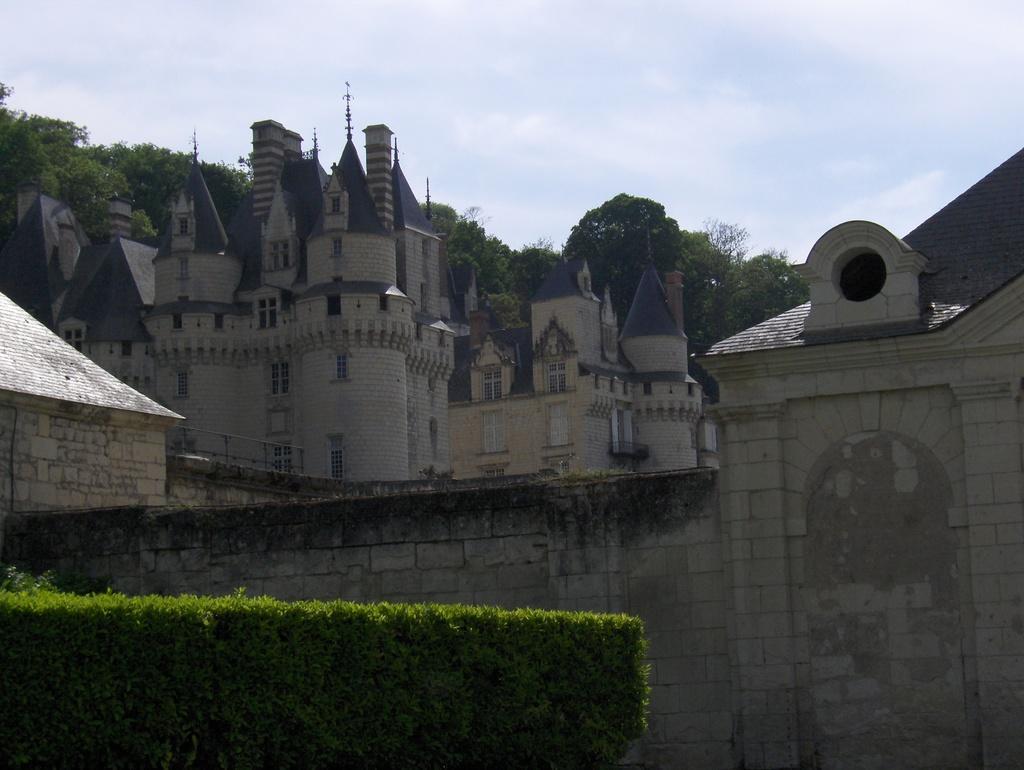How would you summarize this image in a sentence or two? In this image we can see there are buildings, trees, plants and a sky. 